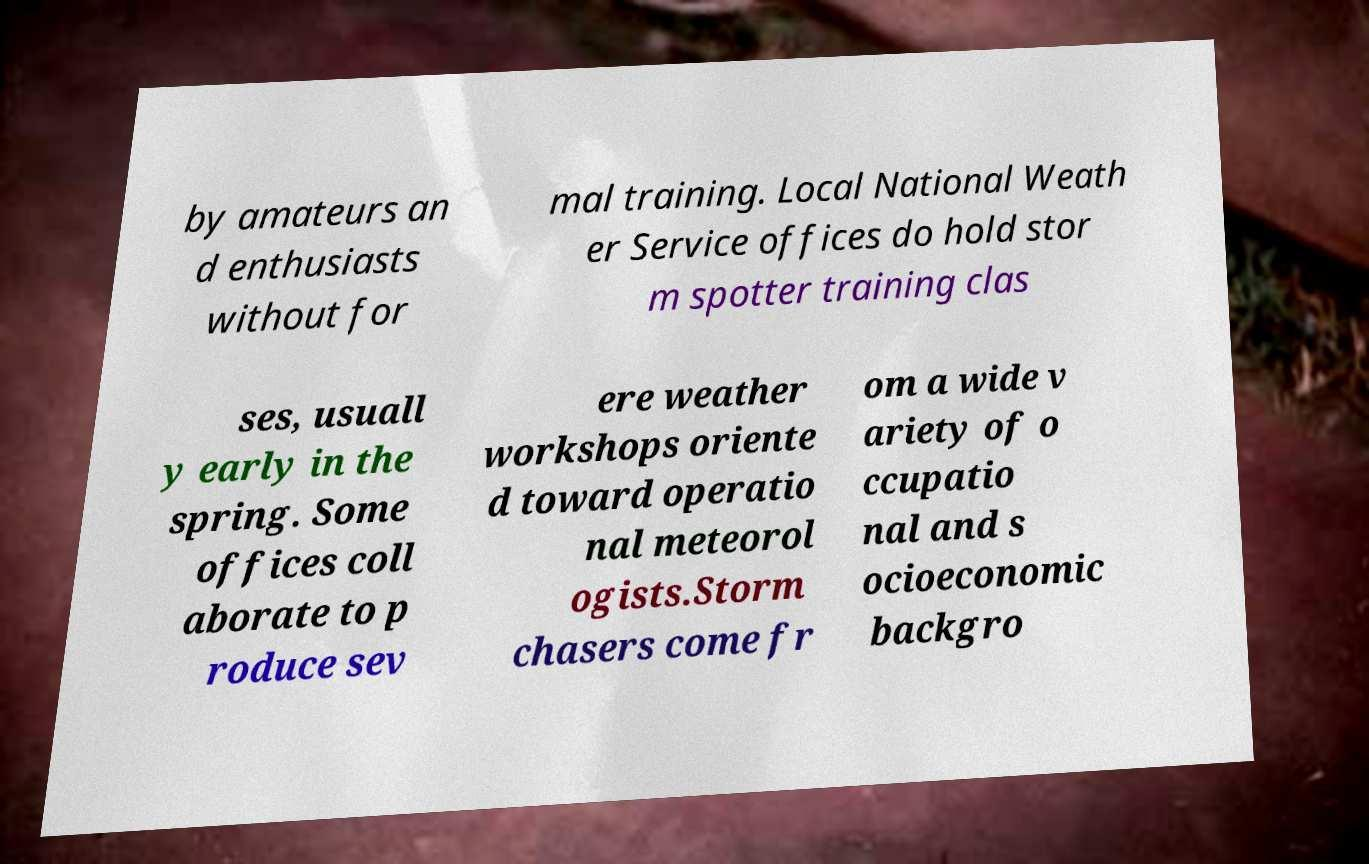Please read and relay the text visible in this image. What does it say? by amateurs an d enthusiasts without for mal training. Local National Weath er Service offices do hold stor m spotter training clas ses, usuall y early in the spring. Some offices coll aborate to p roduce sev ere weather workshops oriente d toward operatio nal meteorol ogists.Storm chasers come fr om a wide v ariety of o ccupatio nal and s ocioeconomic backgro 